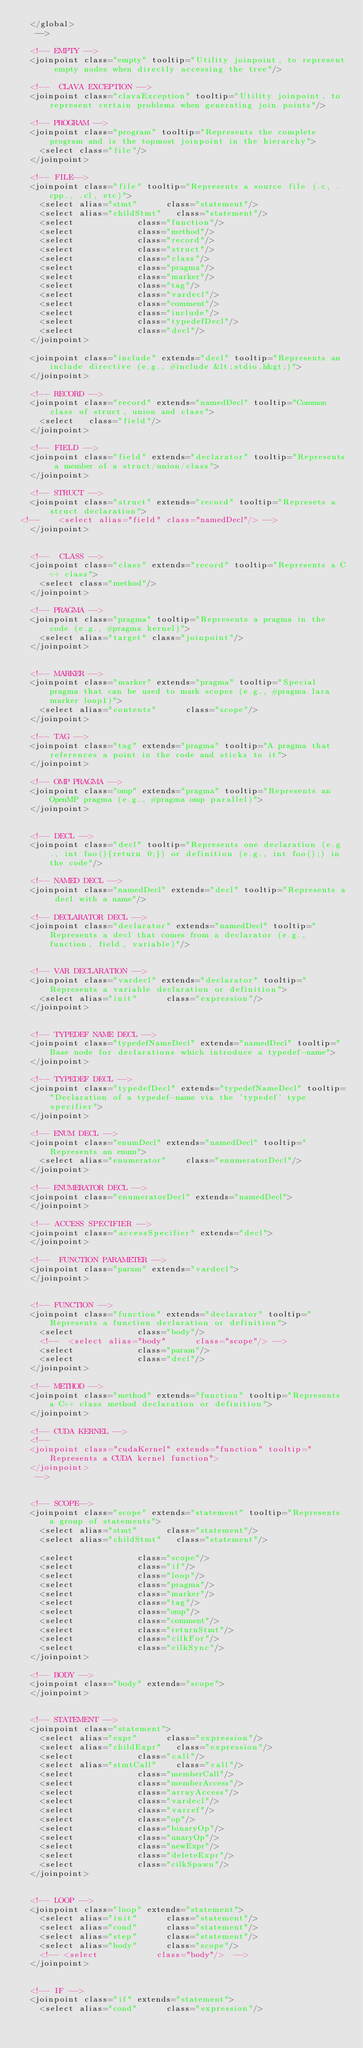<code> <loc_0><loc_0><loc_500><loc_500><_XML_>	</global>
	 -->
	 
	<!-- EMPTY -->
	<joinpoint class="empty" tooltip="Utility joinpoint, to represent empty nodes when directly accessing the tree"/>
	
	<!--  CLAVA EXCEPTION -->
	<joinpoint class="clavaException" tooltip="Utility joinpoint, to represent certain problems when generating join points"/>
	
	<!-- PROGRAM -->
	<joinpoint class="program" tooltip="Represents the complete program and is the topmost joinpoint in the hierarchy">
		<select class="file"/>
	</joinpoint>
	
	<!-- FILE-->
	<joinpoint class="file" tooltip="Represents a source file (.c, .cpp., .cl, etc)">
		<select alias="stmt"			class="statement"/>
		<select alias="childStmt"		class="statement"/>
		<select 						class="function"/>
		<select 						class="method"/>
		<select 						class="record"/>
		<select 						class="struct"/>
		<select 						class="class"/>
		<select							class="pragma"/>
		<select							class="marker"/>
		<select							class="tag"/>		
		<select 						class="vardecl"/>
		<select 						class="comment"/>
		<select 						class="include"/>	
		<select 						class="typedefDecl"/>			
		<select 						class="decl"/>		
	</joinpoint>
	
	<joinpoint class="include" extends="decl" tooltip="Represents an include directive (e.g., #include &lt;stdio.h&gt;)">
	</joinpoint>
	
	<!-- RECORD -->
	<joinpoint class="record" extends="namedDecl" tooltip="Common class of struct, union and class">
		<select 	class="field"/>		
	</joinpoint>
	
	<!-- FIELD -->
	<joinpoint class="field" extends="declarator" tooltip="Represents a member of a struct/union/class">
	</joinpoint>
	
	<!-- STRUCT -->
	<joinpoint class="struct" extends="record" tooltip="Represets a struct declaration">
<!--		<select alias="field"	class="namedDecl"/> -->
	</joinpoint>


	<!--  CLASS -->
	<joinpoint class="class" extends="record" tooltip="Represents a C++ class">
		<select class="method"/>
	</joinpoint>	
	
	<!-- PRAGMA -->
	<joinpoint class="pragma" tooltip="Represents a pragma in the code (e.g., #pragma kernel)">
		<select alias="target" class="joinpoint"/>
	</joinpoint>
	
	
	<!-- MARKER -->
	<joinpoint class="marker" extends="pragma" tooltip="Special pragma that can be used to mark scopes (e.g., #pragma lara marker loop1)">
		<select alias="contents"			class="scope"/>
	</joinpoint>
	
	<!-- TAG -->
	<joinpoint class="tag" extends="pragma" tooltip="A pragma that references a point in the code and sticks to it">
	</joinpoint>
	
	<!-- OMP PRAGMA -->
	<joinpoint class="omp" extends="pragma" tooltip="Represents an OpenMP pragma (e.g., #pragma omp parallel)">
	</joinpoint>
	
	
	<!-- DECL -->
	<joinpoint class="decl" tooltip="Represents one declaration (e.g., int foo(){return 0;}) or definition (e.g., int foo();) in the code"/>
	
	<!-- NAMED DECL -->
	<joinpoint class="namedDecl" extends="decl" tooltip="Represents a decl with a name"/>
	
	<!-- DECLARATOR DECL -->
	<joinpoint class="declarator" extends="namedDecl" tooltip="Represents a decl that comes from a declarator (e.g., function, field, variable)"/>
	
	
	<!-- VAR DECLARATION -->
 	<joinpoint class="vardecl" extends="declarator" tooltip="Represents a variable declaration or definition">
 		<select alias="init"			class="expression"/>
 	</joinpoint>  		
	
	
	<!-- TYPEDEF NAME DECL -->
	<joinpoint class="typedefNameDecl" extends="namedDecl" tooltip="Base node for declarations which introduce a typedef-name">
 	</joinpoint>  		
	
	<!-- TYPEDEF DECL -->
	<joinpoint class="typedefDecl" extends="typedefNameDecl" tooltip="Declaration of a typedef-name via the 'typedef' type specifier">
 	</joinpoint>  		
	
	<!-- ENUM DECL -->
	<joinpoint class="enumDecl" extends="namedDecl" tooltip="Represents an enum">
		<select alias="enumerator" 		class="enumeratorDecl"/>		
 	</joinpoint>  
 	
 	<!-- ENUMERATOR DECL -->
	<joinpoint class="enumeratorDecl" extends="namedDecl">
 	</joinpoint>  
 	
 	<!-- ACCESS SPECIFIER -->
	<joinpoint class="accessSpecifier" extends="decl">
 	</joinpoint>  	
	
	<!--  FUNCTION PARAMETER -->
	<joinpoint class="param" extends="vardecl">
	</joinpoint>


	<!-- FUNCTION -->
	<joinpoint class="function" extends="declarator" tooltip="Represents a function declaration or definition">
		<select 						class="body"/> 
	 	<!--  <select alias="body" 			class="scope"/> -->
		<select 						class="param"/>
		<select 						class="decl"/>
	</joinpoint>
		
	<!-- METHOD -->
	<joinpoint class="method" extends="function" tooltip="Represents a C++ class method declaration or definition">
	</joinpoint>			

	<!-- CUDA KERNEL -->
	<!-- 
	<joinpoint class="cudaKernel" extends="function" tooltip="Represents a CUDA kernel function">
	</joinpoint>			
	 -->
	 	
		
	<!-- SCOPE-->
	<joinpoint class="scope" extends="statement" tooltip="Represents a group of statements">
		<select alias="stmt"			class="statement"/> 
		<select alias="childStmt"		class="statement"/>
		
		<select							class="scope"/>
		<select							class="if"/>
		<select							class="loop"/>
		<select							class="pragma"/>
		<select							class="marker"/>
		<select							class="tag"/>	
		<select							class="omp"/>	
		<select 						class="comment"/>
		<select 						class="returnStmt"/>		
		<select 						class="cilkFor"/>
		<select 						class="cilkSync"/>
	</joinpoint>
	
	<!-- BODY -->
	<joinpoint class="body" extends="scope">
	</joinpoint> 
	
	
	<!-- STATEMENT -->
	<joinpoint class="statement">
		<select alias="expr"			class="expression"/>
		<select alias="childExpr"		class="expression"/>
		<select 						class="call"/>
 		<select alias="stmtCall"		class="call"/>
 		<select 						class="memberCall"/>
		<select							class="memberAccess"/>
 		<select							class="arrayAccess"/>
 		<select 						class="vardecl"/>
		<select 						class="varref"/>
		<select							class="op"/>		
		<select							class="binaryOp"/>
		<select							class="unaryOp"/>
		<select							class="newExpr"/>
		<select							class="deleteExpr"/>		
		<select							class="cilkSpawn"/>				
	</joinpoint>
	

	<!-- LOOP -->
	<joinpoint class="loop" extends="statement">
		<select alias="init"			class="statement"/>	
		<select alias="cond"			class="statement"/>
		<select alias="step"			class="statement"/>
		<select alias="body" 			class="scope"/> 
		<!-- <select 			 			class="body"/>  -->
	</joinpoint>	

	 
	<!-- IF -->
	<joinpoint class="if" extends="statement">
		<select alias="cond"			class="expression"/></code> 